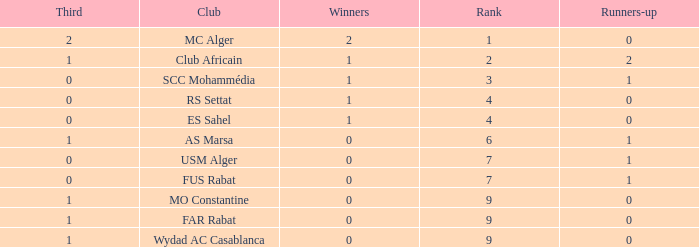How many Winners have a Third of 1, and Runners-up smaller than 0? 0.0. 